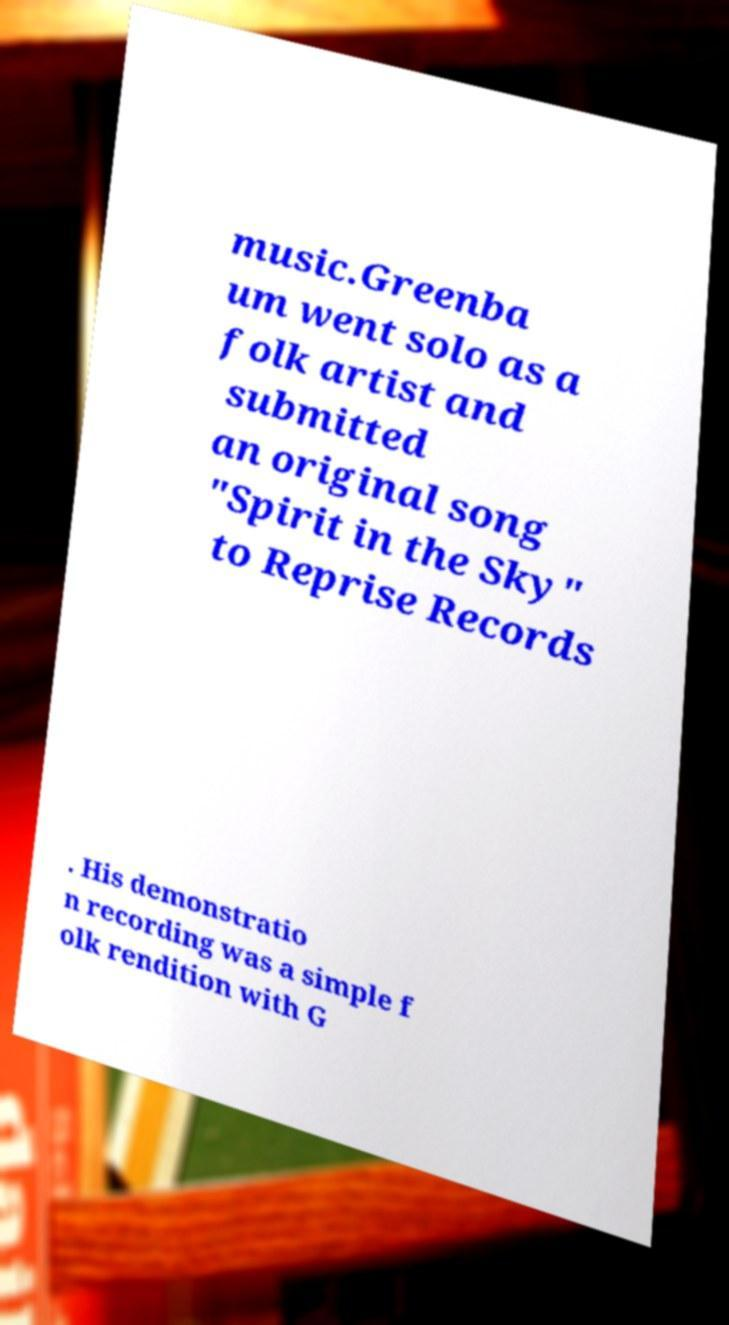Please read and relay the text visible in this image. What does it say? music.Greenba um went solo as a folk artist and submitted an original song "Spirit in the Sky" to Reprise Records . His demonstratio n recording was a simple f olk rendition with G 